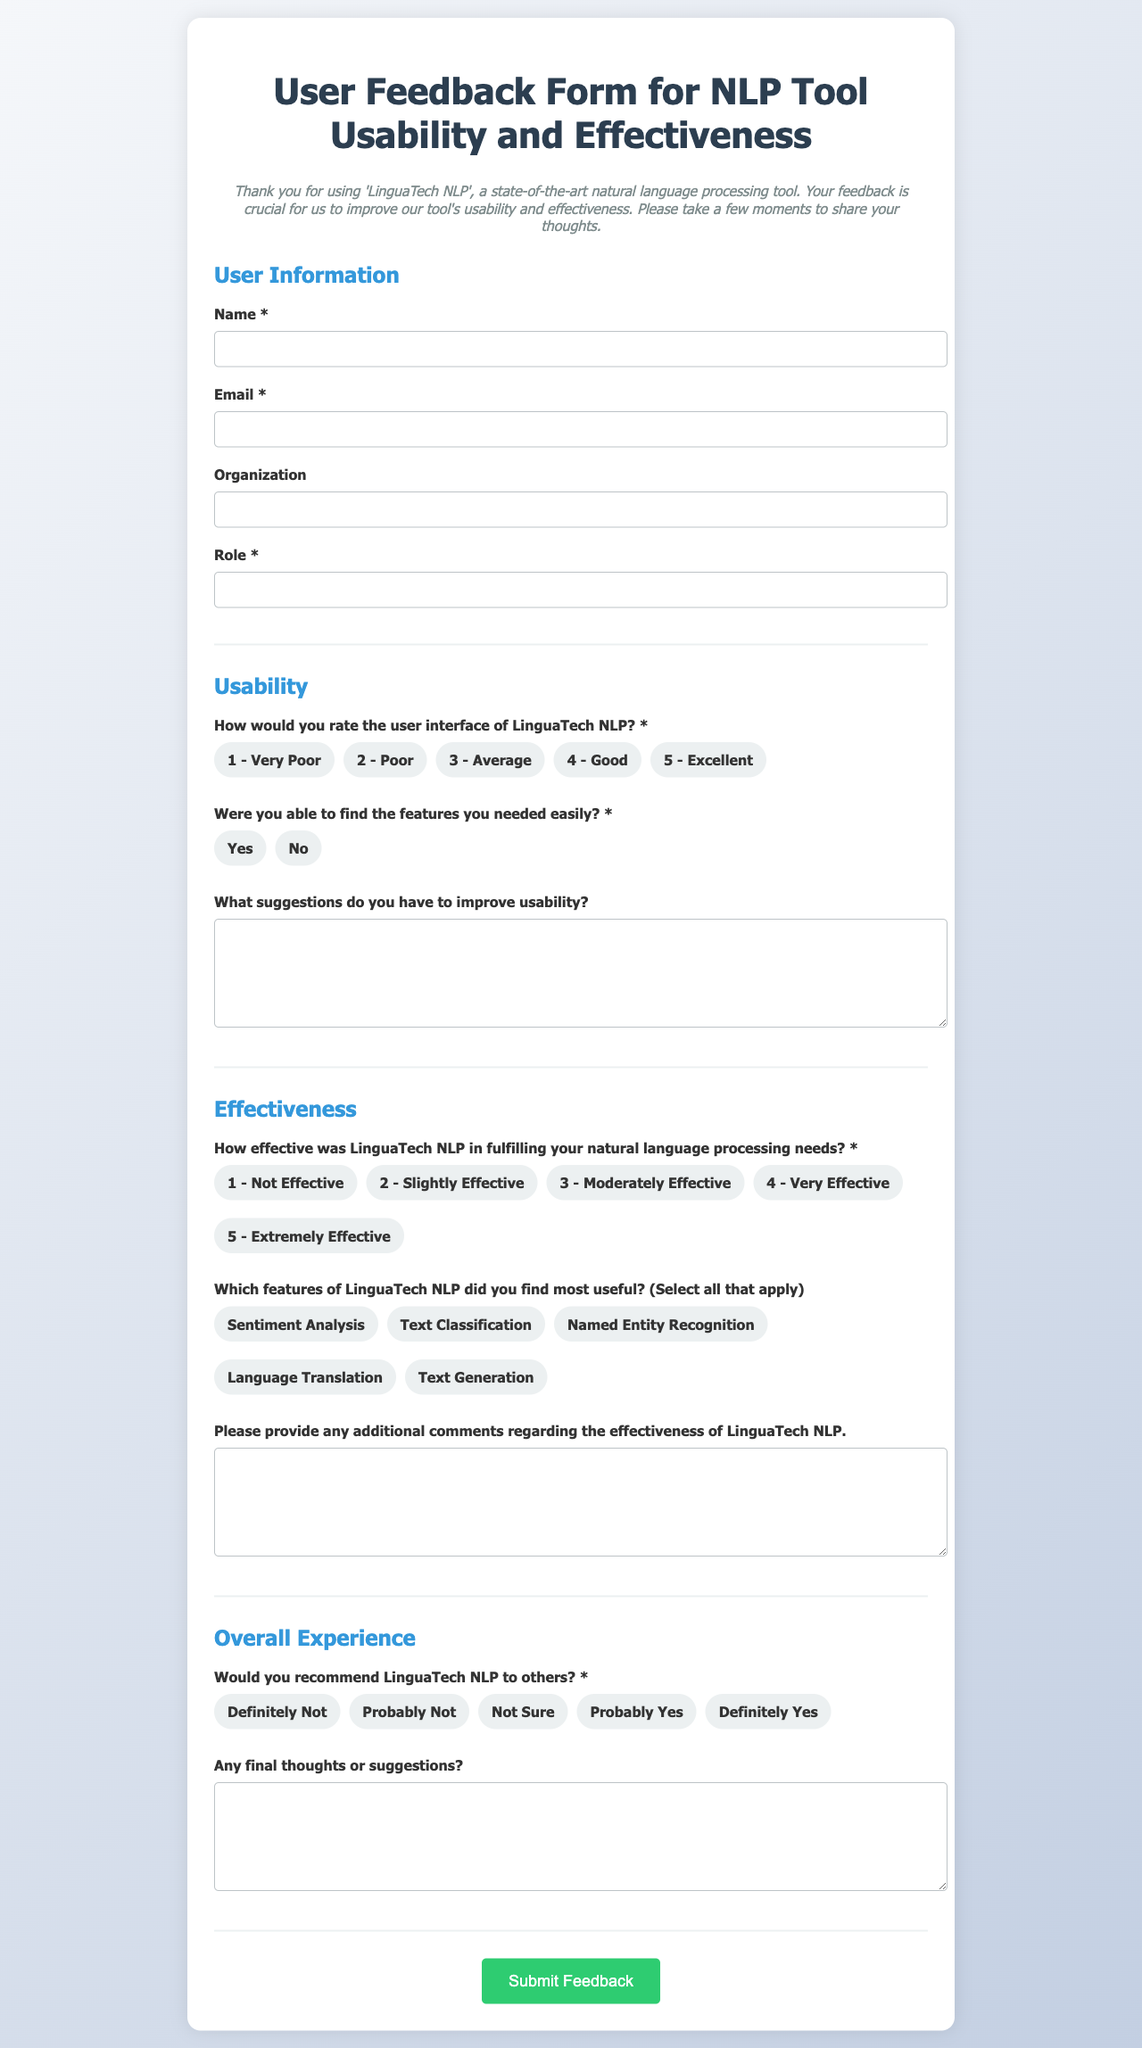What is the title of the form? The title is provided at the top of the document and indicates the purpose of the form.
Answer: User Feedback Form for NLP Tool Usability and Effectiveness Who is the NLP tool developed by? The introduction mentions the name of the NLP tool which is the focus of the feedback form.
Answer: LinguaTech NLP How many sections are in the form? The form contains multiple sections designed to gather different types of feedback.
Answer: Four What rating is the lowest option for the user interface question? The rating options provide a range for respondents to evaluate the user interface.
Answer: 1 - Very Poor Which feature is listed as the last option under useful features? The features provided for selection cover various capabilities of the NLP tool, with the last option specified.
Answer: Text Generation What type of feedback does the section titled "Overall Experience" ask for? This section typically gathers general impressions and final thoughts from users regarding their experience with the tool.
Answer: Recommendation and final thoughts Which type of feedback question does the section on usability include? The usability section focuses on specific elements of the user experience, inquiring about ease of use.
Answer: Usability suggestions How many choices is given for recommending the tool? The recommendation question allows respondents to express their likelihood of suggesting the tool to others.
Answer: Five What text area asks for additional comments? The form provides an area for users to elaborate on their thoughts regarding the effectiveness of the tool.
Answer: Effectiveness comments 